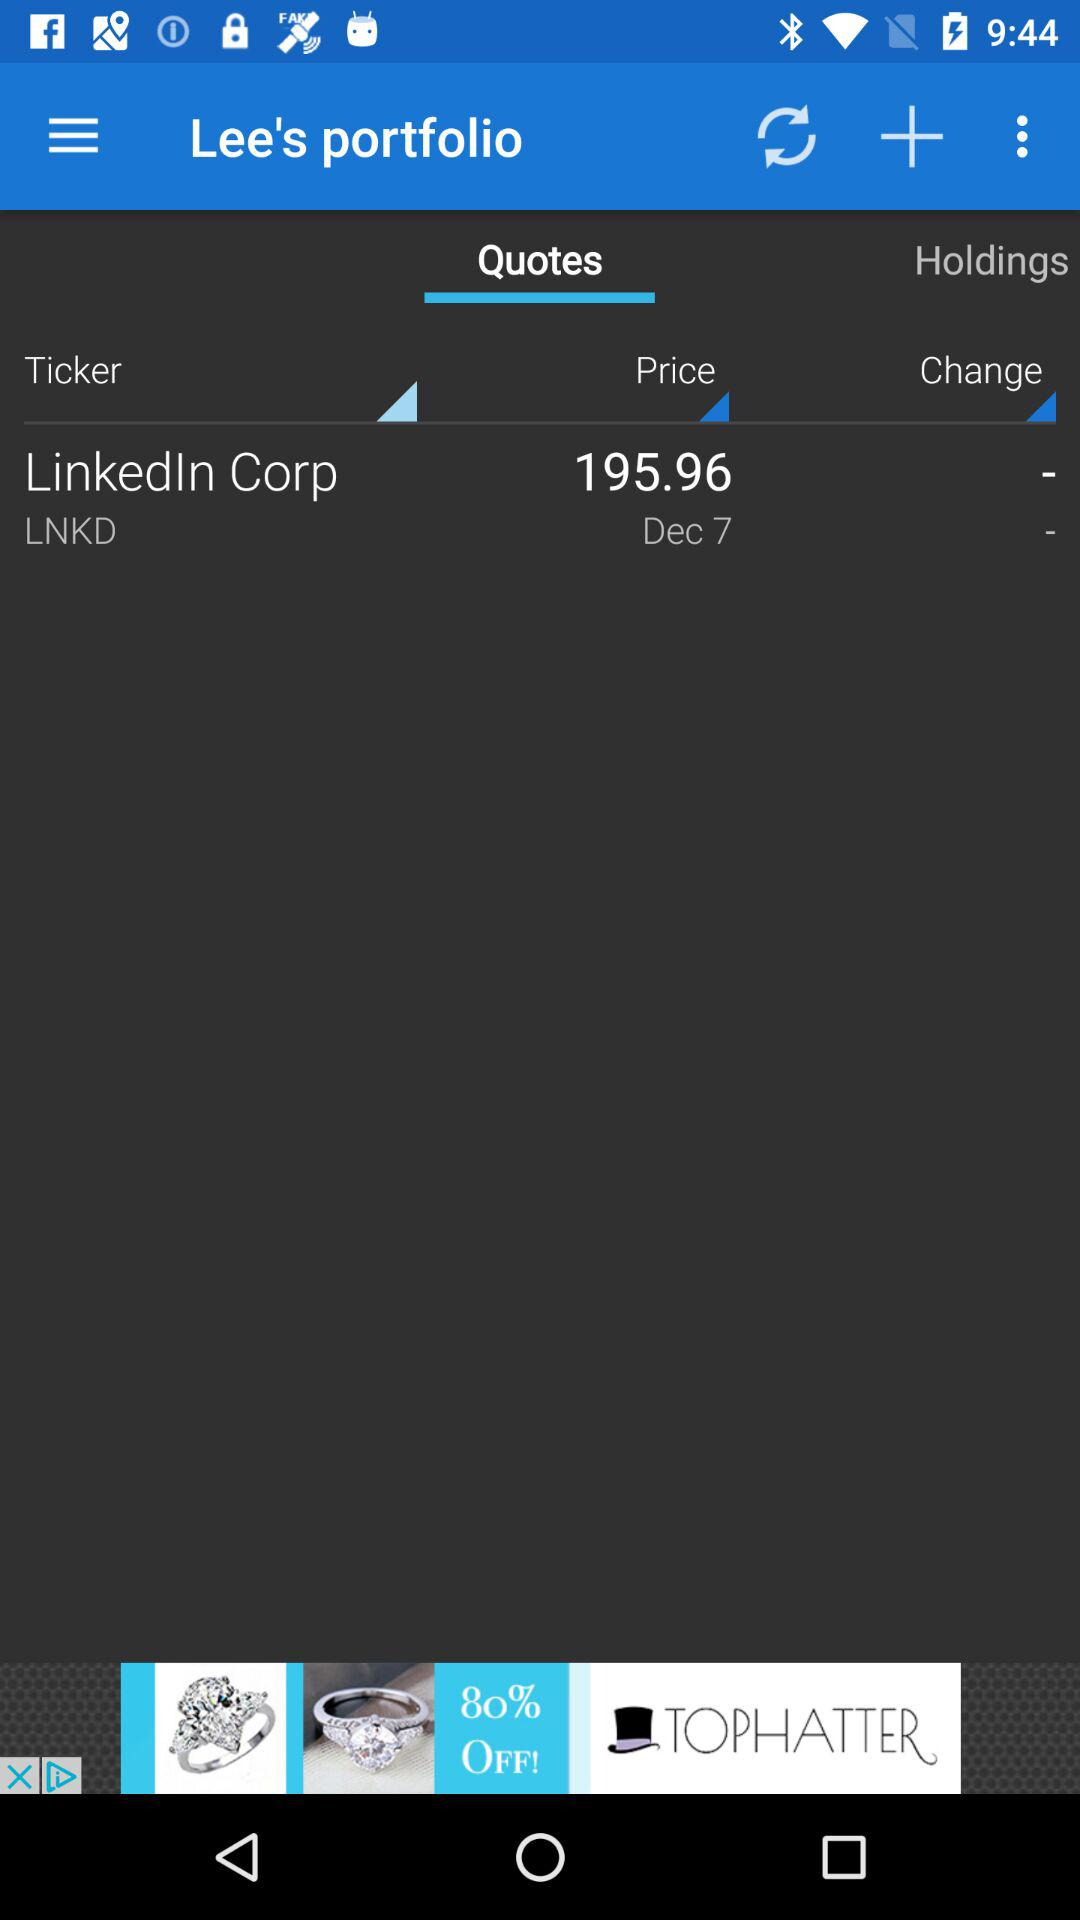What is the date? The date is December 7. 